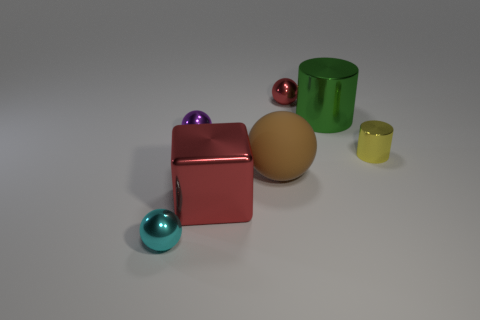How many large things are the same shape as the small red object? 1 